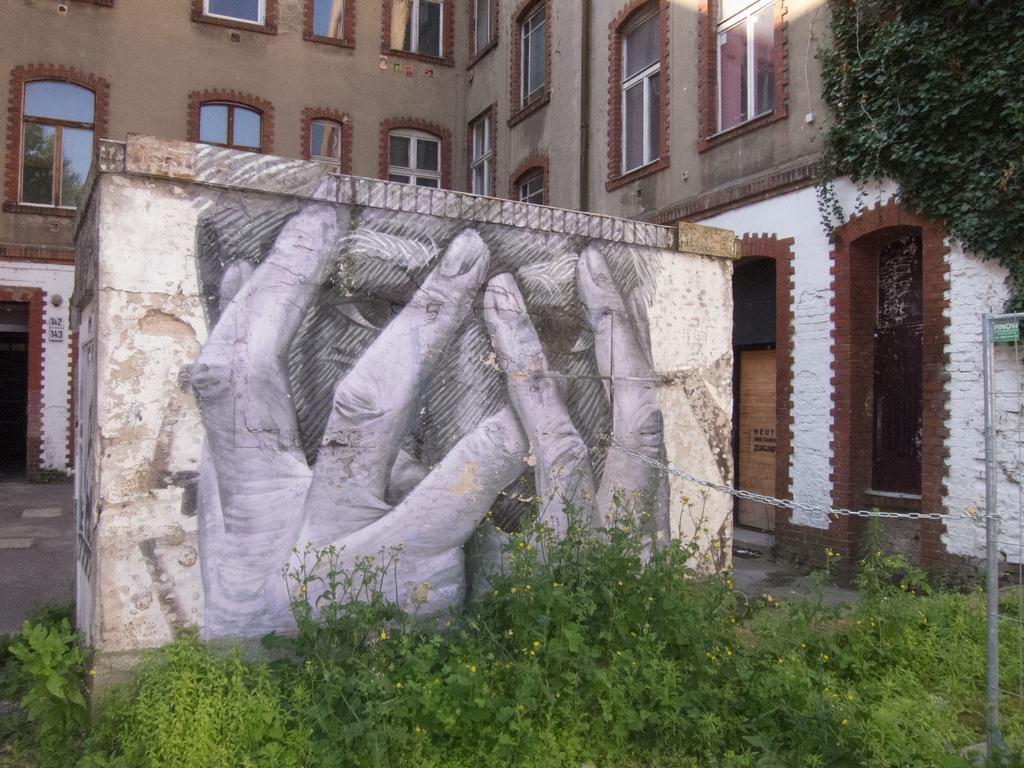How would you summarize this image in a sentence or two? Here we can see plants, pole, and a chain. There is a drawing on the wall. In the background we can see a building, windows, and boards. 